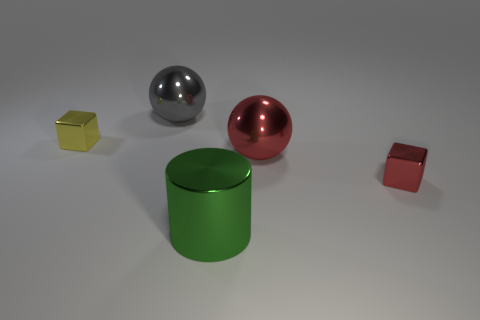Add 3 small matte cylinders. How many objects exist? 8 Subtract all balls. How many objects are left? 3 Subtract 1 gray spheres. How many objects are left? 4 Subtract all metal spheres. Subtract all tiny red shiny blocks. How many objects are left? 2 Add 4 shiny cubes. How many shiny cubes are left? 6 Add 5 metallic objects. How many metallic objects exist? 10 